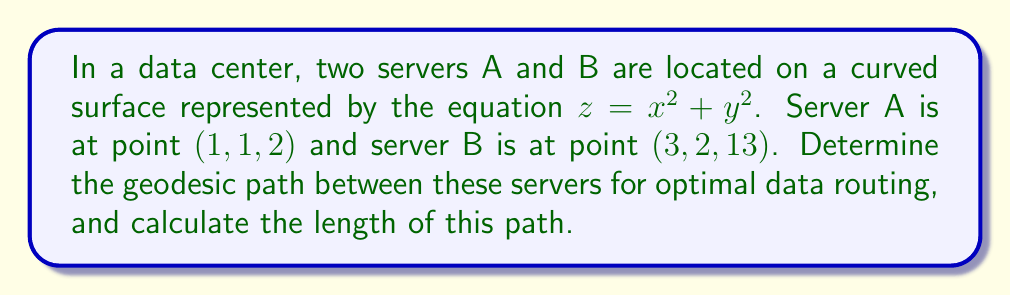Can you solve this math problem? To solve this problem, we'll follow these steps:

1) First, we need to parameterize the surface. Let's use the parametrization:
   $$\mathbf{r}(u,v) = (u, v, u^2 + v^2)$$

2) The metric tensor for this surface is:
   $$g_{ij} = \begin{pmatrix}
   1 + 4u^2 & 4uv \\
   4uv & 1 + 4v^2
   \end{pmatrix}$$

3) The geodesic equations for this surface are:
   $$\frac{d^2u}{dt^2} + \Gamma^u_{uu}\left(\frac{du}{dt}\right)^2 + 2\Gamma^u_{uv}\frac{du}{dt}\frac{dv}{dt} + \Gamma^u_{vv}\left(\frac{dv}{dt}\right)^2 = 0$$
   $$\frac{d^2v}{dt^2} + \Gamma^v_{uu}\left(\frac{du}{dt}\right)^2 + 2\Gamma^v_{uv}\frac{du}{dt}\frac{dv}{dt} + \Gamma^v_{vv}\left(\frac{dv}{dt}\right)^2 = 0$$

   Where the Christoffel symbols are:
   $$\Gamma^u_{uu} = \frac{2u}{1+4u^2}, \Gamma^u_{uv} = \Gamma^u_{vu} = -\frac{2v}{1+4u^2}, \Gamma^u_{vv} = 0$$
   $$\Gamma^v_{uu} = 0, \Gamma^v_{uv} = \Gamma^v_{vu} = -\frac{2u}{1+4v^2}, \Gamma^v_{vv} = \frac{2v}{1+4v^2}$$

4) These differential equations need to be solved numerically with the boundary conditions:
   $$u(0) = 1, v(0) = 1, u(1) = 3, v(1) = 2$$

5) Using a numerical solver (like Runge-Kutta method), we can obtain the geodesic path $(u(t), v(t))$ for $t \in [0,1]$.

6) The length of the geodesic can be calculated using the integral:
   $$L = \int_0^1 \sqrt{g_{11}\left(\frac{du}{dt}\right)^2 + 2g_{12}\frac{du}{dt}\frac{dv}{dt} + g_{22}\left(\frac{dv}{dt}\right)^2} dt$$

7) This integral can be evaluated numerically using the solutions for $u(t)$ and $v(t)$.

Note: The exact numerical results would depend on the specific numerical methods used.
Answer: Geodesic path: $(u(t), v(t), u(t)^2 + v(t)^2)$ for $t \in [0,1]$, where $u(t)$ and $v(t)$ are numerical solutions to the geodesic equations. 